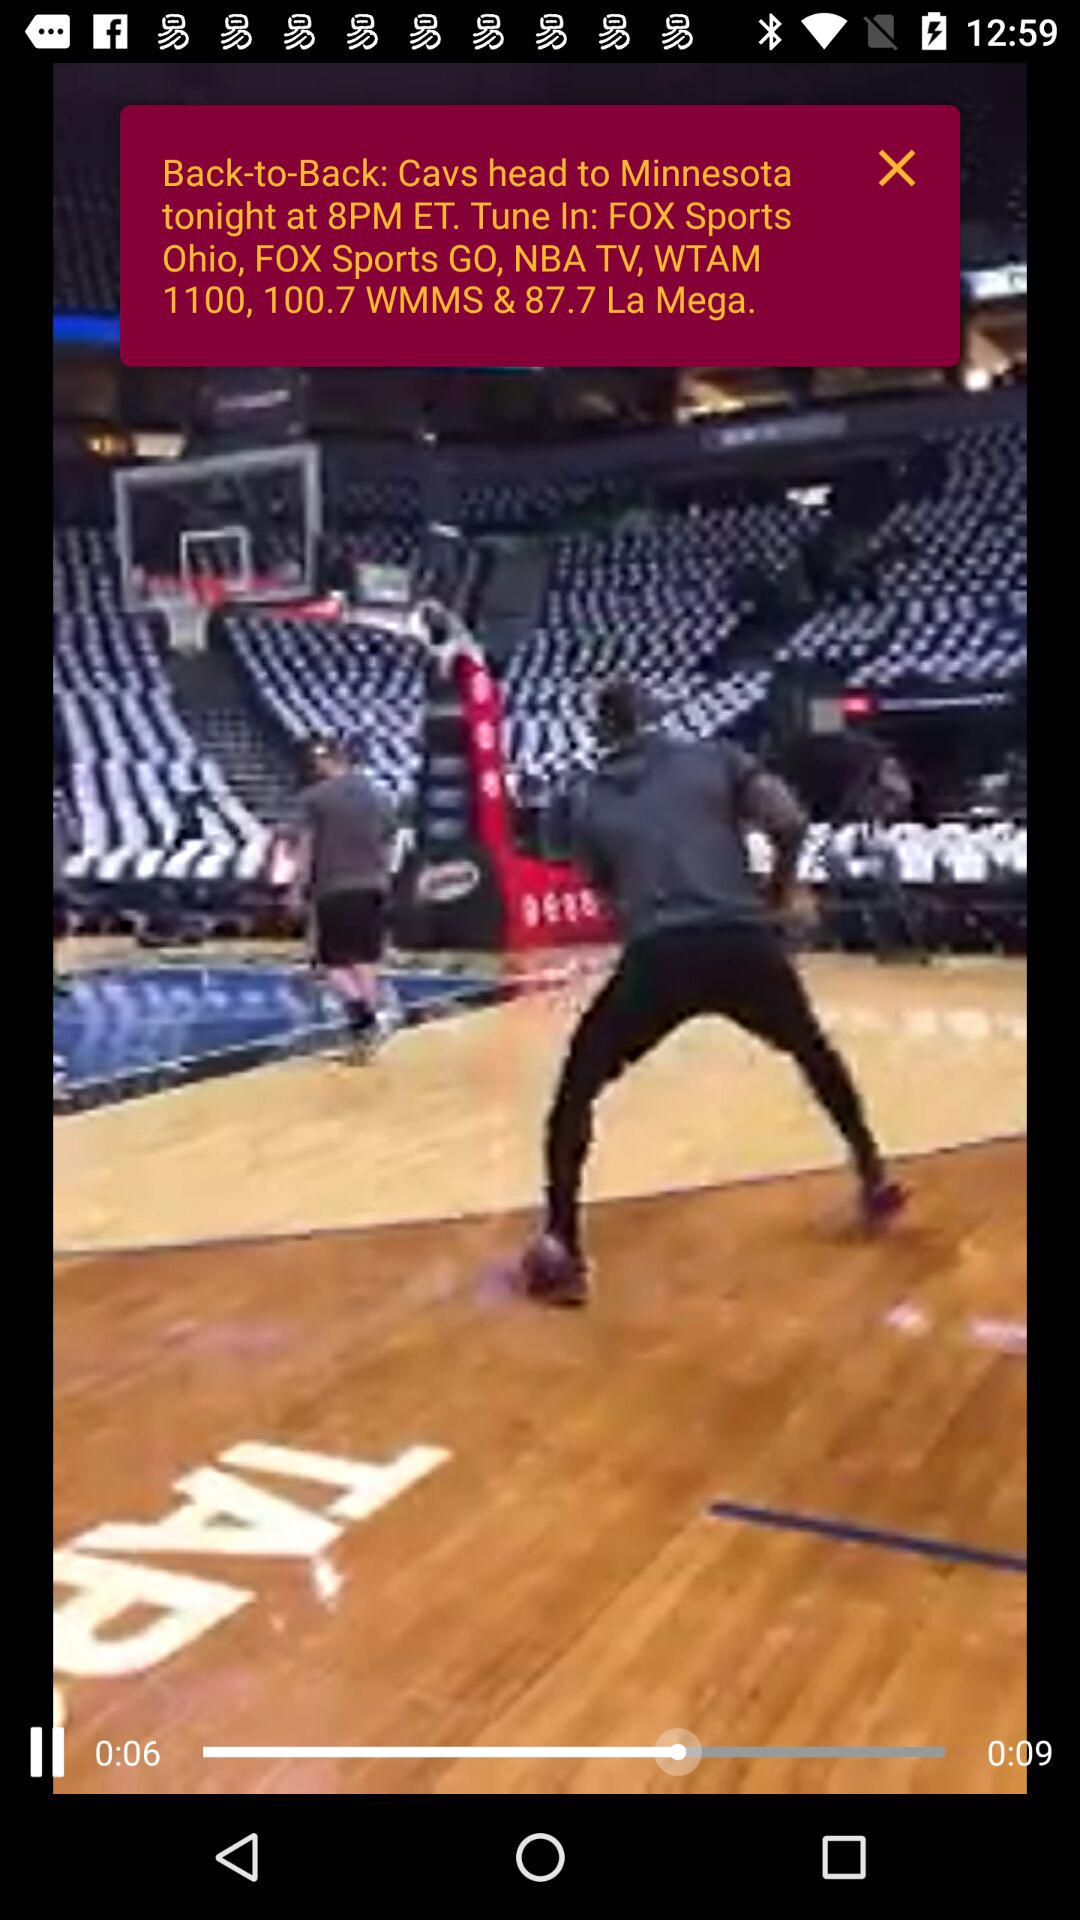What is the time of "Back-to-Back: Cavs head to Minnesota"? The time of "Back-to-Back: Cavs head to Minnesota" is 8 PM. 